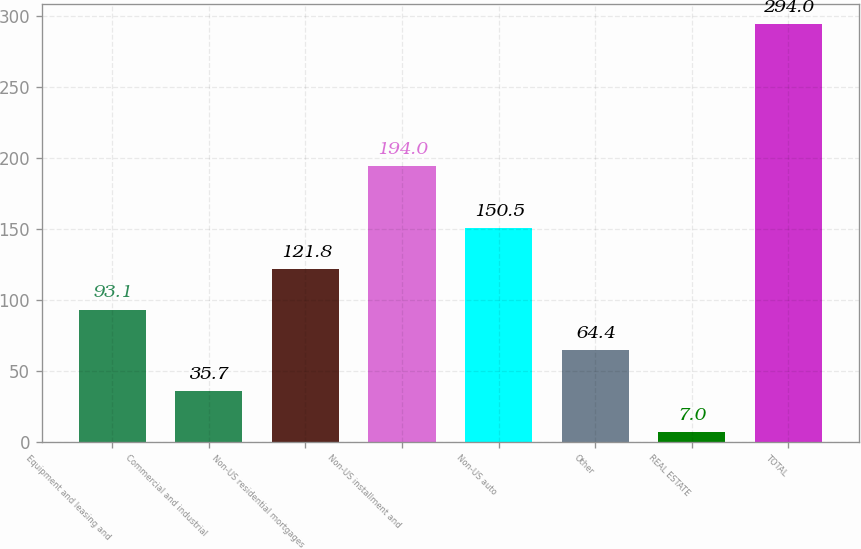Convert chart. <chart><loc_0><loc_0><loc_500><loc_500><bar_chart><fcel>Equipment and leasing and<fcel>Commercial and industrial<fcel>Non-US residential mortgages<fcel>Non-US installment and<fcel>Non-US auto<fcel>Other<fcel>REAL ESTATE<fcel>TOTAL<nl><fcel>93.1<fcel>35.7<fcel>121.8<fcel>194<fcel>150.5<fcel>64.4<fcel>7<fcel>294<nl></chart> 